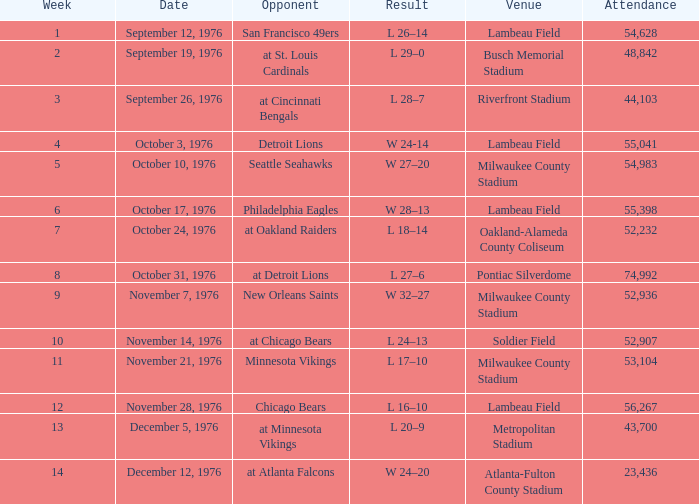What is the mean attendance for the match on september 26, 1976? 44103.0. 